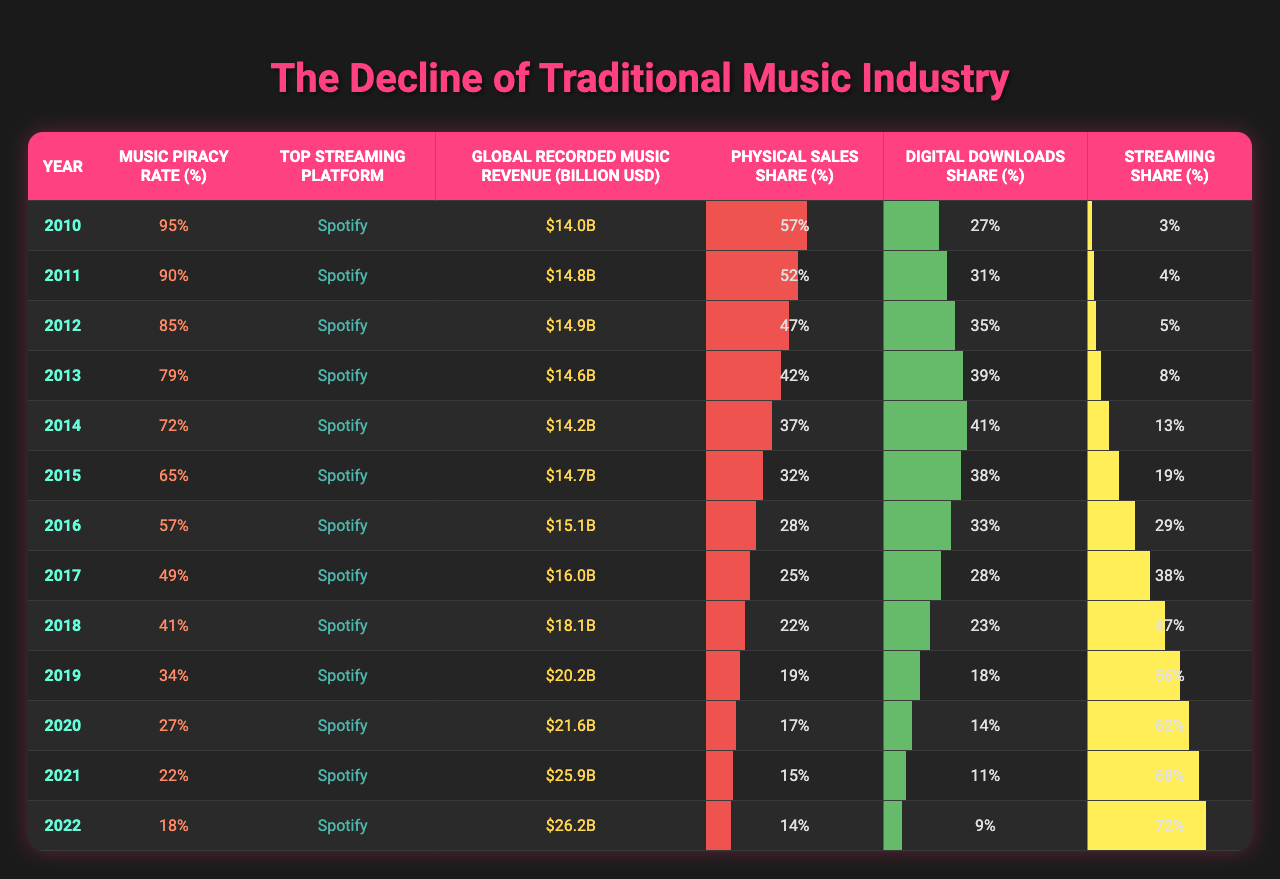What was the music piracy rate in 2010? From the table, the music piracy rate for the year 2010 is clearly stated in the second column. It is 95%.
Answer: 95% How much was the global recorded music revenue in 2019? The global recorded music revenue for the year 2019 is found in the fourth column. It shows that the revenue was $20.2 billion.
Answer: $20.2 billion What percentage of music sales was made up by streaming in 2022? Referring to the streaming share column for the year 2022, it indicates that streaming made up 72% of music sales.
Answer: 72% Did the music piracy rate decrease every year from 2010 to 2022? By examining the piracy rates listed for each year from 2010 to 2022, it's evident that the percentage consistently dropped each year, confirming that the rate indeed decreased.
Answer: Yes What was the difference in music piracy rate between 2016 and 2020? The piracy rate for 2016 is 57% and for 2020 is 27%. Subtracting these values (57% - 27%) results in a difference of 30%.
Answer: 30% What was the average streaming share percentage for the years 2010 to 2015? Adding the streaming shares from 2010 to 2015, we get (3 + 4 + 5 + 8 + 13 + 19 = 52). There are 6 years, so dividing the total by 6 gives an average of approximately 8.67%.
Answer: 8.67% Which year had the highest share of physical sales? The physical sales share is highest in 2010 at 57%, according to the table, as all the other years have lower values.
Answer: 2010 What trend can be observed in the relationship between streaming share and music piracy rate from 2010 to 2022? The table shows that as the streaming share increased over the years from 2010 to 2022, the music piracy rate decreased, indicating an inverse relationship.
Answer: Inverse relationship What was the percentage of digital downloads in 2018 compared to 2021? The digital downloads share for 2018 is 23% and for 2021 it is 11%. The difference is (23% - 11%) = 12% lower in 2021.
Answer: 12% lower Was the top streaming platform consistent throughout the years? Examining the table, the top streaming platform is listed as Spotify for every year from 2010 to 2022, showing consistency.
Answer: Yes 